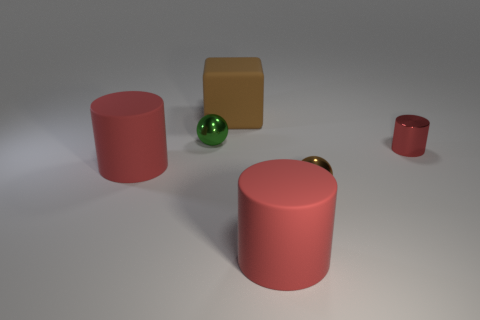Subtract all big red cylinders. How many cylinders are left? 1 Add 4 blue blocks. How many objects exist? 10 Subtract all green spheres. How many spheres are left? 1 Subtract all balls. How many objects are left? 4 Subtract 1 cubes. How many cubes are left? 0 Subtract all gray cylinders. Subtract all green cubes. How many cylinders are left? 3 Subtract all small red metallic cubes. Subtract all metal objects. How many objects are left? 3 Add 3 spheres. How many spheres are left? 5 Add 6 small cylinders. How many small cylinders exist? 7 Subtract 0 gray cylinders. How many objects are left? 6 